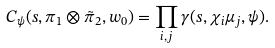<formula> <loc_0><loc_0><loc_500><loc_500>C _ { \psi } ( s , \pi _ { 1 } \otimes \tilde { \pi } _ { 2 } , w _ { 0 } ) = \prod _ { i , j } \gamma ( s , \chi _ { i } \mu _ { j } , \psi ) .</formula> 